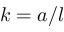<formula> <loc_0><loc_0><loc_500><loc_500>k = a / l</formula> 